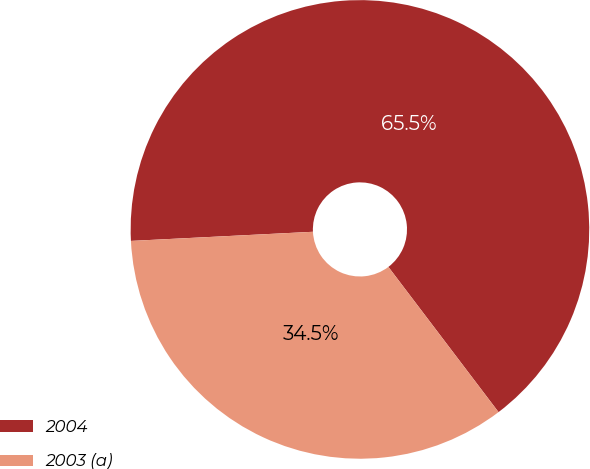Convert chart. <chart><loc_0><loc_0><loc_500><loc_500><pie_chart><fcel>2004<fcel>2003 (a)<nl><fcel>65.47%<fcel>34.53%<nl></chart> 